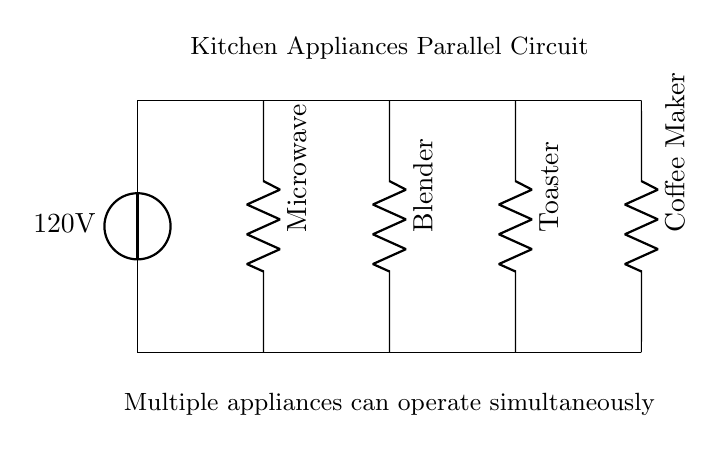What is the source voltage of the circuit? The circuit diagram shows the voltage source marked as 120V, which supplies power to the parallel circuit.
Answer: 120V What appliances are connected to this circuit? The circuit diagram depicts four appliances: Microwave, Blender, Toaster, and Coffee Maker connected in parallel.
Answer: Microwave, Blender, Toaster, Coffee Maker How many appliances can operate simultaneously? In a parallel circuit configuration, all appliances can operate at the same time, as they are connected across the same voltage source without affecting each other.
Answer: All What type of circuit is shown in the diagram? The circuit diagram clearly indicates a parallel circuit, where multiple branches are powered by the same voltage source, allowing each appliance to operate independently.
Answer: Parallel Which appliance is located in the middle of the circuit? The Blender is positioned in the center of the circuit diagram, between the Microwave and the Toaster, indicating its relative location among the appliances.
Answer: Blender What is the main benefit of connecting appliances in parallel? Connecting appliances in parallel allows each one to receive the full voltage supply from the source, ensuring consistent operation without voltage drop across other appliances.
Answer: Consistent operation 